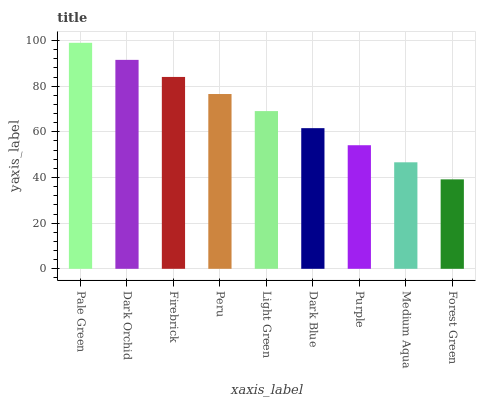Is Forest Green the minimum?
Answer yes or no. Yes. Is Pale Green the maximum?
Answer yes or no. Yes. Is Dark Orchid the minimum?
Answer yes or no. No. Is Dark Orchid the maximum?
Answer yes or no. No. Is Pale Green greater than Dark Orchid?
Answer yes or no. Yes. Is Dark Orchid less than Pale Green?
Answer yes or no. Yes. Is Dark Orchid greater than Pale Green?
Answer yes or no. No. Is Pale Green less than Dark Orchid?
Answer yes or no. No. Is Light Green the high median?
Answer yes or no. Yes. Is Light Green the low median?
Answer yes or no. Yes. Is Pale Green the high median?
Answer yes or no. No. Is Purple the low median?
Answer yes or no. No. 